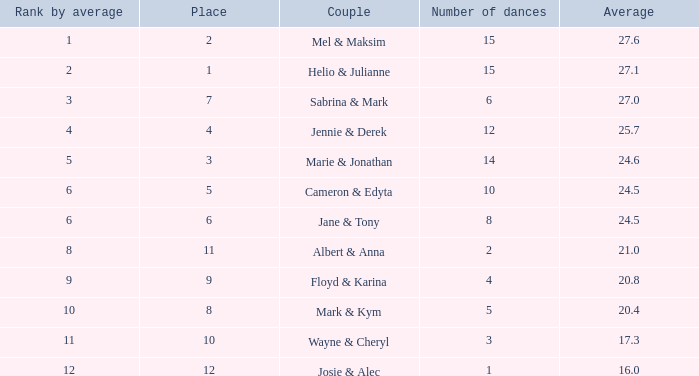What is the mean when the ranking by average surpasses 12? None. 